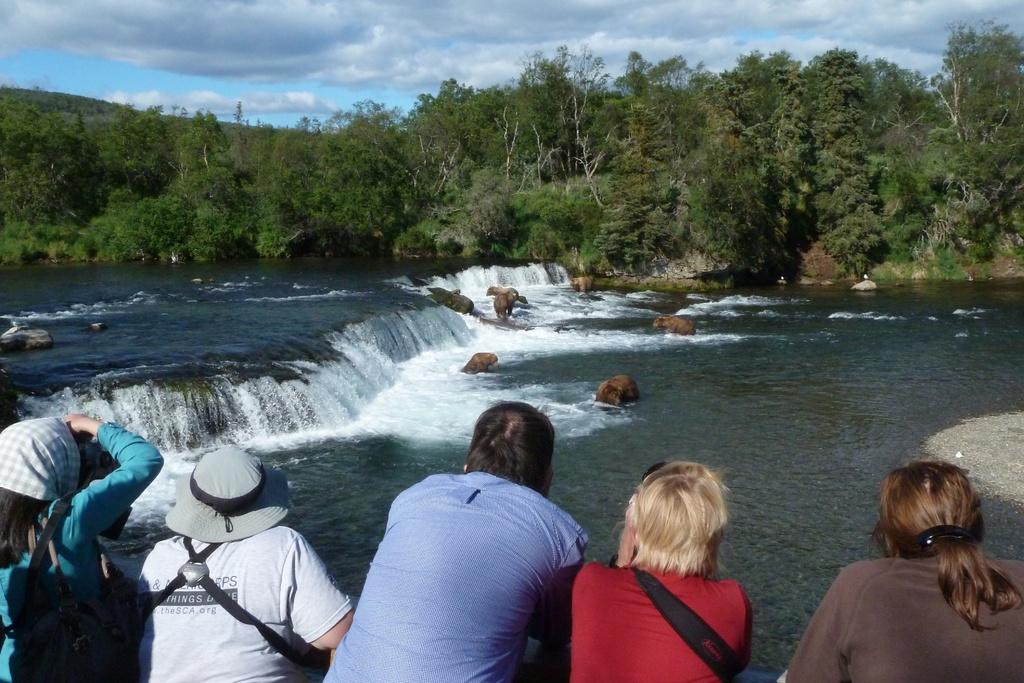What are the people in the image wearing on their heads? The people in the image are wearing hats. What else are the people wearing in the image? The people are also wearing scarves. What can be seen in the background of the image? There is a river, a small waterfall, rocks, trees, and the sky visible in the background of the image. What is the condition of the sky in the image? The sky is visible in the background of the image, and there are clouds present. What decision does the fireman make in the image? There is no fireman present in the image, so no decision can be made by a fireman. What type of basin is visible in the image? There is no basin present in the image. 